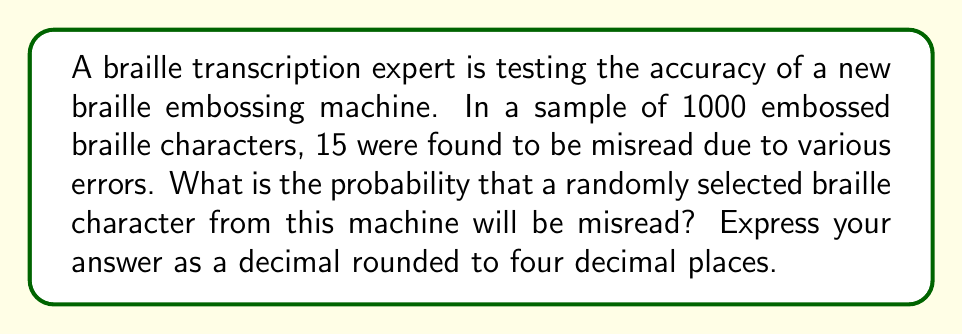Can you solve this math problem? To solve this problem, we need to use the concept of probability based on relative frequency. Here's a step-by-step explanation:

1) First, let's identify the key information:
   - Total number of braille characters: 1000
   - Number of misread characters: 15

2) The probability of an event is calculated by dividing the number of favorable outcomes by the total number of possible outcomes:

   $$P(\text{event}) = \frac{\text{number of favorable outcomes}}{\text{total number of possible outcomes}}$$

3) In this case:
   - The event we're interested in is a character being misread
   - The number of favorable outcomes is 15 (misread characters)
   - The total number of possible outcomes is 1000 (total characters)

4) Let's plug these numbers into our probability formula:

   $$P(\text{misread}) = \frac{15}{1000}$$

5) Now, let's perform the division:

   $$P(\text{misread}) = 0.015$$

6) The question asks for the answer rounded to four decimal places, which is already the case here.

Therefore, the probability of a randomly selected braille character being misread is 0.0150 or 1.50%.
Answer: 0.0150 